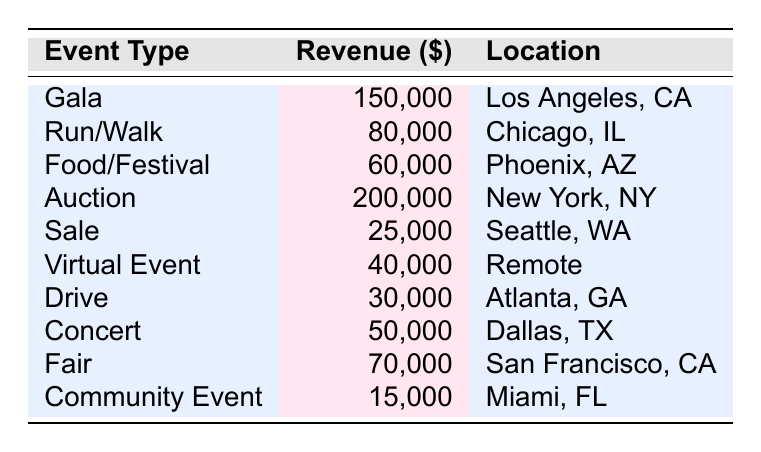What is the total revenue generated by the "Auction" event? The table shows that the "Auction" event has a revenue of 200,000.
Answer: 200000 Which event type generated the highest revenue? Looking at the revenue column, "Auction" has the highest revenue at 200,000.
Answer: Auction What is the revenue from events held in Atlanta, GA? The table shows that the "Drive" event held in Atlanta, GA generated 30,000 in revenue.
Answer: 30000 What is the average revenue of all the fundraising events listed? To find the average, sum up all the revenues: 150000 + 80000 + 60000 + 200000 + 25000 + 40000 + 30000 + 50000 + 70000 + 15000 = 600000. There are 10 events, so the average is 600000 / 10 = 60000.
Answer: 60000 Is there any event that generated less than 20,000 in revenue? The table shows that the lowest revenue is from "Pet Adoption Day Fundraiser," which generated 15,000. Therefore, there is an event with less than 20,000.
Answer: Yes How much more revenue did the "Gala" event generate compared to the "Sale" event? The "Gala" generated 150,000 and the "Sale" generated 25,000. The difference is 150000 - 25000 = 125000.
Answer: 125000 How many events had revenues between 50,000 and 100,000? The events that fit this criterion are "Run/Walk" (80,000), "Food/Festival" (60,000), and "Concert" (50,000). Therefore, there are 3 events.
Answer: 3 Which location had the lowest revenue event, and what was the amount? The "Pet Adoption Day Fundraiser" in Miami, FL had the lowest revenue, which was 15,000.
Answer: Miami, FL; 15000 What is the total revenue from events located in California? The events in California are "Annual Charity Gala" (150,000) and "Book Fair for Literacy" (70,000). So, the total revenue is 150000 + 70000 = 220000.
Answer: 220000 Is the revenue from the "Virtual Event" higher than the revenue from the "Drive"? The "Virtual Event" generated 40,000 while the "Drive" generated 30,000. Since 40,000 is greater than 30,000, the revenue from the "Virtual Event" is indeed higher than that from the "Drive."
Answer: Yes 